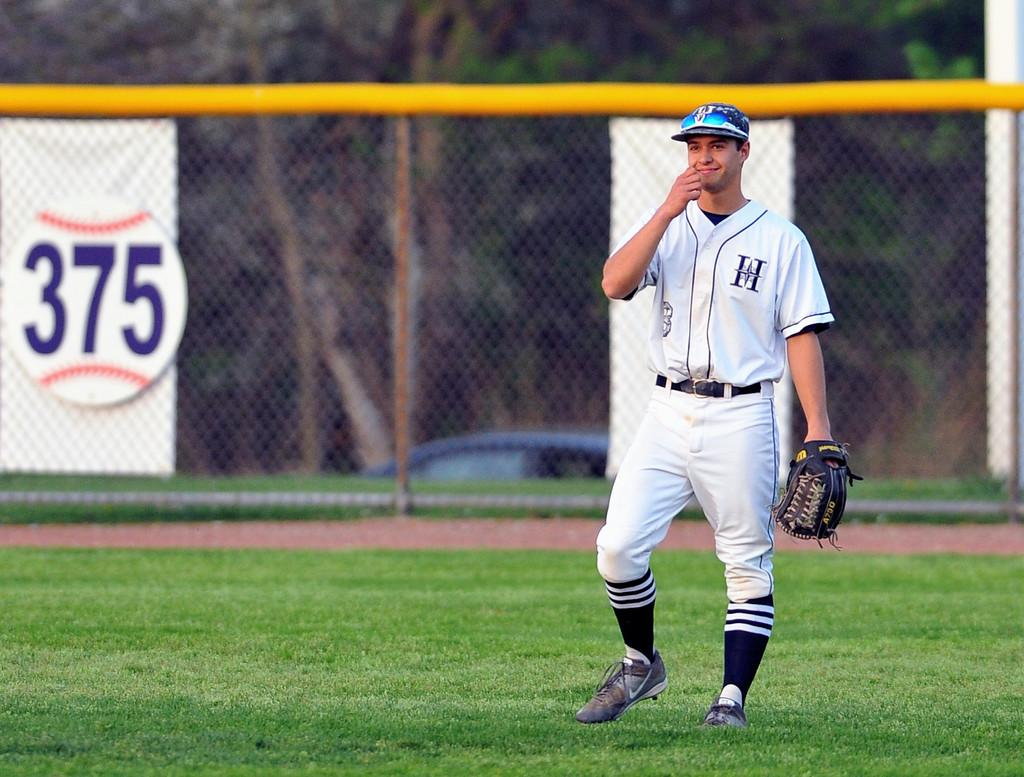<image>
Offer a succinct explanation of the picture presented. A baseball logo with 375 hangs on a fence with a baseball player holding a mitt 